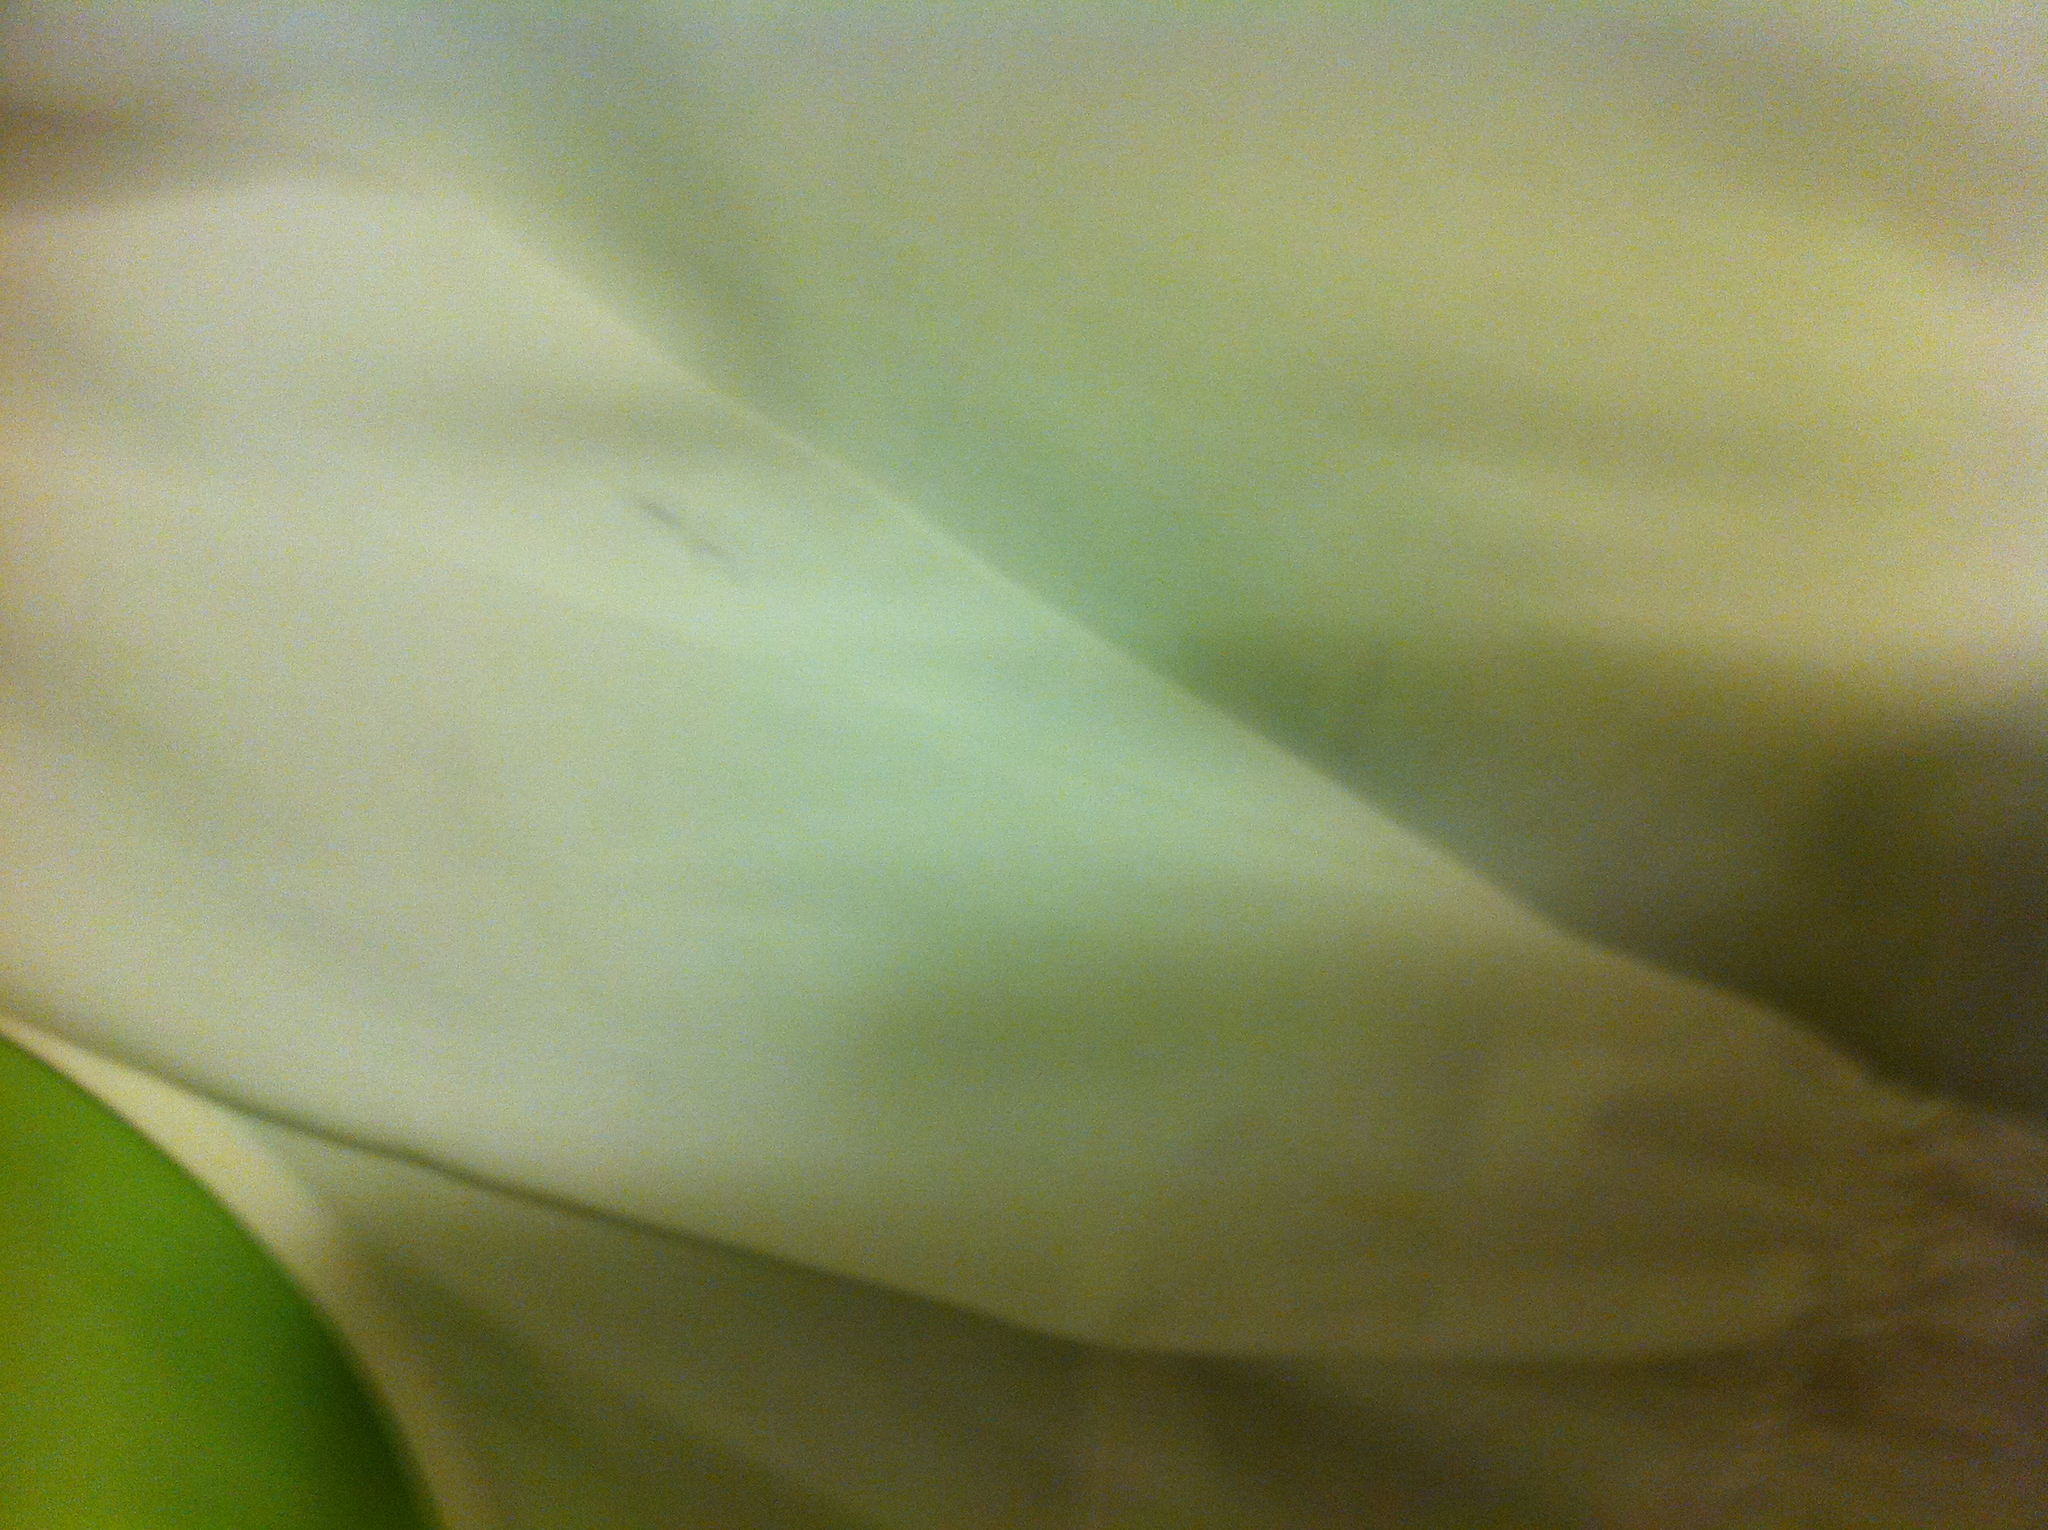What color shirt is this? The shirt displayed in the image appears to be white, with a smooth texture that suggests a soft, comfortable fabric. 